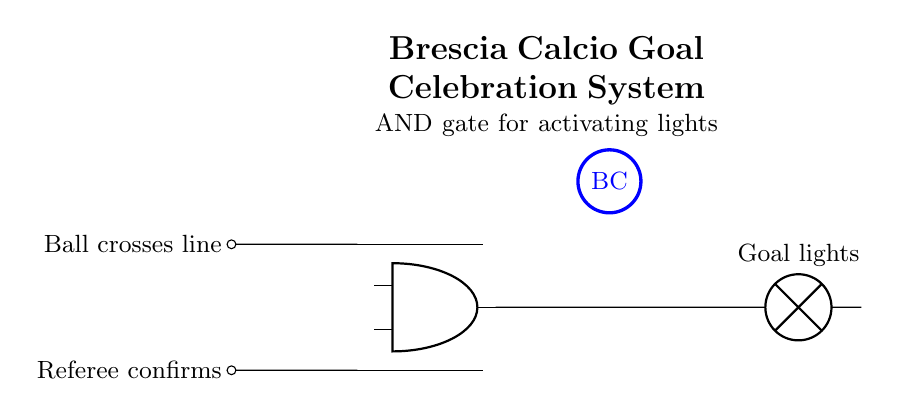What are the two inputs to the AND gate? The two inputs are "Ball crosses line" and "Referee confirms." These are indicated by the labels on the left side of the circuit diagram.
Answer: Ball crosses line, Referee confirms What component indicates the goal celebration action? The lamp symbolizes the goal celebration lights, as denoted in the output section of the circuit. It illustrates what happens when the AND gate outputs a signal.
Answer: Goal lights How many inputs does the AND gate have? The AND gate has two inputs, which are necessary for its logical operation to function correctly in this circuit.
Answer: Two What does the AND gate output when both inputs are high? The output will activate the goal lights, signifying that both conditions (ball crossing the line and referee confirmation) are satisfied.
Answer: Goal lights Why is an AND gate used in this circuit? The AND gate is utilized because it requires both conditions to be true in order to activate the goal celebration lights, which aligns with the requirement for a goal.
Answer: To ensure both conditions What color is the Brescia Calcio logo in the circuit design? The Brescia Calcio logo is drawn in blue, as indicated by the thick blue circle in the circuit diagram.
Answer: Blue 